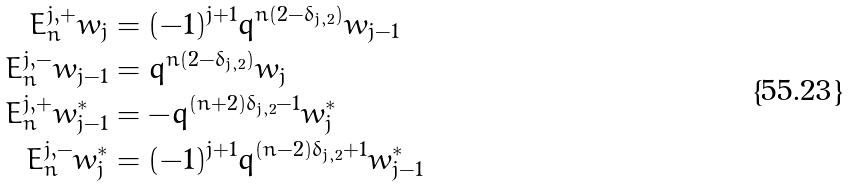Convert formula to latex. <formula><loc_0><loc_0><loc_500><loc_500>E ^ { j , + } _ { n } w _ { j } & = ( - 1 ) ^ { j + 1 } q ^ { n ( 2 - \delta _ { j , 2 } ) } w _ { j - 1 } \\ E ^ { j , - } _ { n } w _ { j - 1 } & = q ^ { n ( 2 - \delta _ { j , 2 } ) } w _ { j } \\ E ^ { j , + } _ { n } w ^ { * } _ { j - 1 } & = - q ^ { ( n + 2 ) \delta _ { j , 2 } - 1 } w ^ { * } _ { j } \\ E ^ { j , - } _ { n } w ^ { * } _ { j } & = ( - 1 ) ^ { j + 1 } q ^ { ( n - 2 ) \delta _ { j , 2 } + 1 } w ^ { * } _ { j - 1 }</formula> 